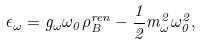Convert formula to latex. <formula><loc_0><loc_0><loc_500><loc_500>\epsilon _ { \omega } = g _ { \omega } \omega _ { 0 } \rho _ { B } ^ { r e n } - \frac { 1 } { 2 } m _ { \omega } ^ { 2 } \omega _ { 0 } ^ { 2 } ,</formula> 